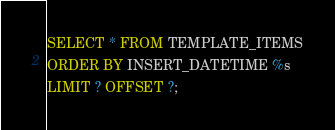<code> <loc_0><loc_0><loc_500><loc_500><_SQL_>SELECT * FROM TEMPLATE_ITEMS
ORDER BY INSERT_DATETIME %s
LIMIT ? OFFSET ?;
</code> 